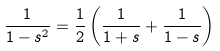Convert formula to latex. <formula><loc_0><loc_0><loc_500><loc_500>\frac { 1 } { 1 - s ^ { 2 } } = \frac { 1 } { 2 } \left ( \frac { 1 } { 1 + s } + \frac { 1 } { 1 - s } \right )</formula> 